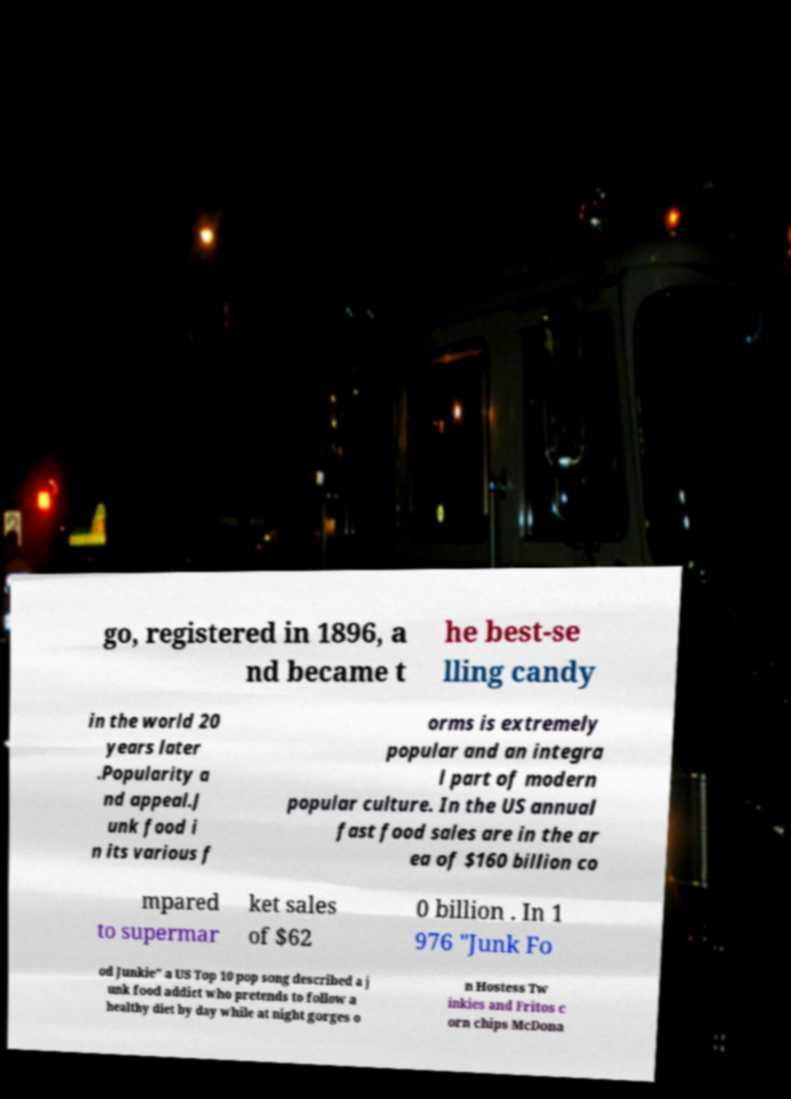Can you accurately transcribe the text from the provided image for me? go, registered in 1896, a nd became t he best-se lling candy in the world 20 years later .Popularity a nd appeal.J unk food i n its various f orms is extremely popular and an integra l part of modern popular culture. In the US annual fast food sales are in the ar ea of $160 billion co mpared to supermar ket sales of $62 0 billion . In 1 976 "Junk Fo od Junkie" a US Top 10 pop song described a j unk food addict who pretends to follow a healthy diet by day while at night gorges o n Hostess Tw inkies and Fritos c orn chips McDona 